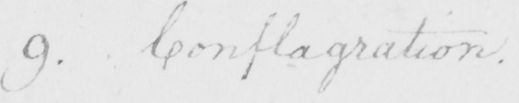Transcribe the text shown in this historical manuscript line. 9 . Conflagration . 